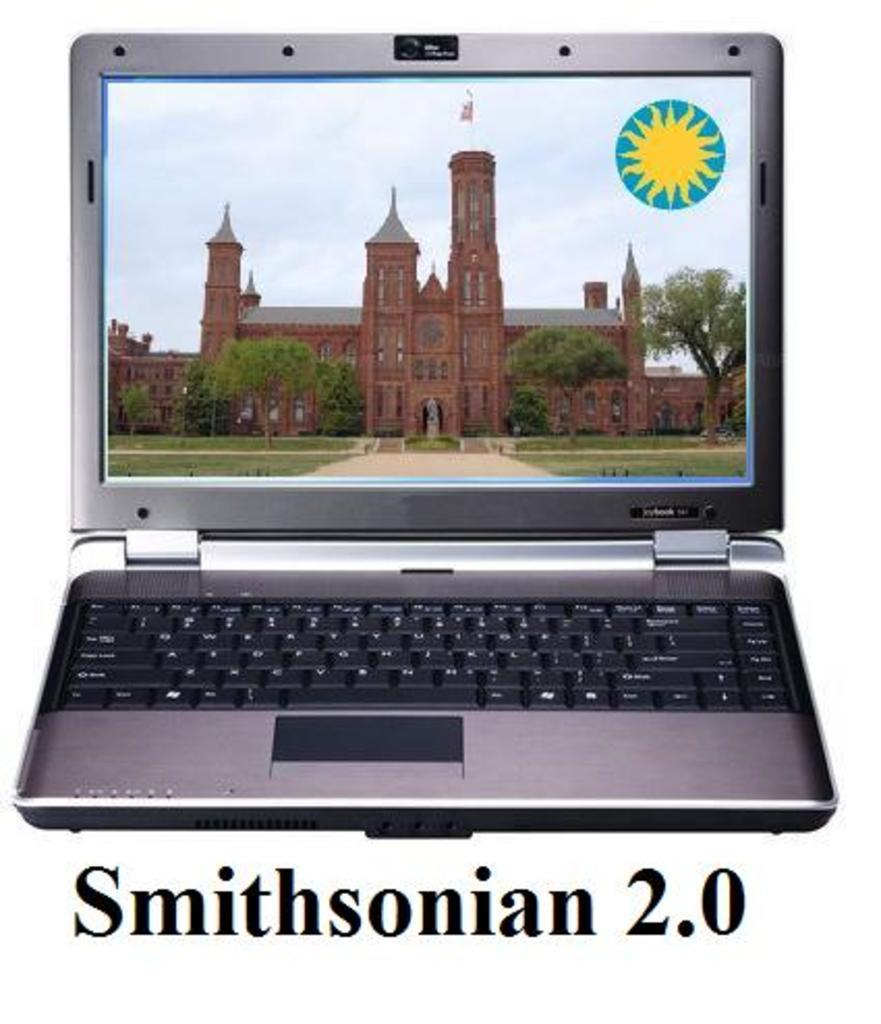<image>
Present a compact description of the photo's key features. An old brick building called the Smithsonian is shown on a laptop screen. 